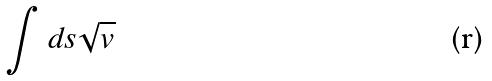<formula> <loc_0><loc_0><loc_500><loc_500>\int d s \sqrt { v }</formula> 